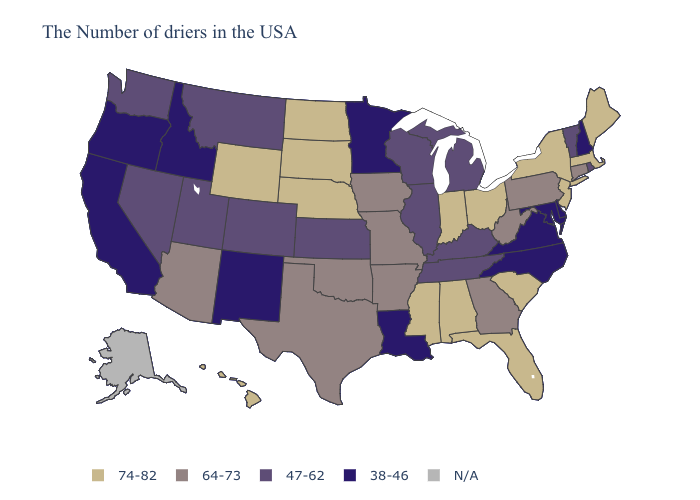Name the states that have a value in the range 64-73?
Write a very short answer. Connecticut, Pennsylvania, West Virginia, Georgia, Missouri, Arkansas, Iowa, Oklahoma, Texas, Arizona. Name the states that have a value in the range N/A?
Answer briefly. Alaska. Does Tennessee have the highest value in the USA?
Concise answer only. No. What is the lowest value in the MidWest?
Short answer required. 38-46. Name the states that have a value in the range 64-73?
Concise answer only. Connecticut, Pennsylvania, West Virginia, Georgia, Missouri, Arkansas, Iowa, Oklahoma, Texas, Arizona. What is the lowest value in states that border Nevada?
Keep it brief. 38-46. Name the states that have a value in the range N/A?
Be succinct. Alaska. Name the states that have a value in the range N/A?
Give a very brief answer. Alaska. What is the value of Rhode Island?
Concise answer only. 47-62. Which states hav the highest value in the South?
Write a very short answer. South Carolina, Florida, Alabama, Mississippi. Name the states that have a value in the range N/A?
Answer briefly. Alaska. Among the states that border New Mexico , does Oklahoma have the lowest value?
Give a very brief answer. No. What is the lowest value in states that border Iowa?
Answer briefly. 38-46. What is the value of Idaho?
Concise answer only. 38-46. 